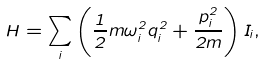Convert formula to latex. <formula><loc_0><loc_0><loc_500><loc_500>H = \sum _ { i } \left ( \frac { 1 } { 2 } m \omega ^ { 2 } _ { i } q ^ { 2 } _ { i } + \frac { p ^ { 2 } _ { i } } { 2 m } \right ) I _ { i } ,</formula> 